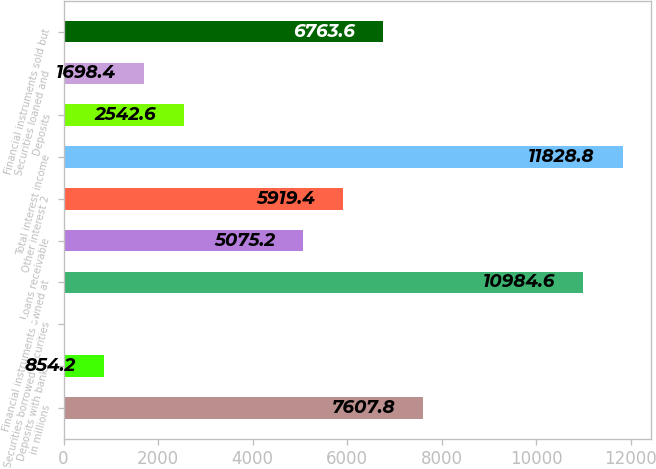<chart> <loc_0><loc_0><loc_500><loc_500><bar_chart><fcel>in millions<fcel>Deposits with banks<fcel>Securities borrowed securities<fcel>Financial instruments owned at<fcel>Loans receivable<fcel>Other interest 2<fcel>Total interest income<fcel>Deposits<fcel>Securities loaned and<fcel>Financial instruments sold but<nl><fcel>7607.8<fcel>854.2<fcel>10<fcel>10984.6<fcel>5075.2<fcel>5919.4<fcel>11828.8<fcel>2542.6<fcel>1698.4<fcel>6763.6<nl></chart> 